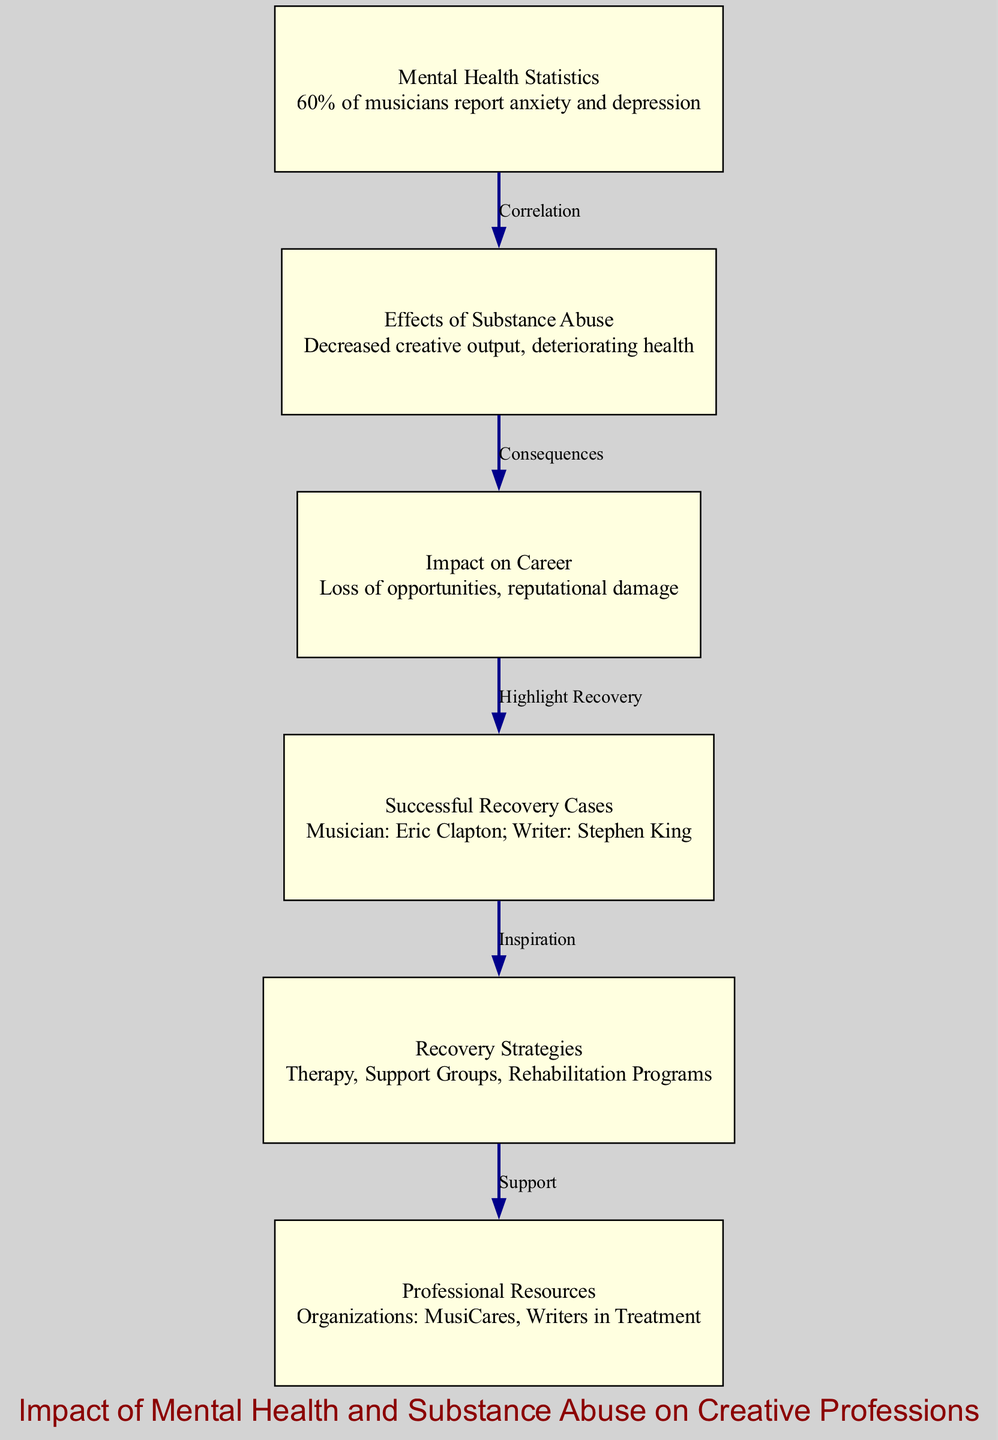What percentage of musicians report anxiety and depression? The diagram states that 60% of musicians report anxiety and depression, which is found in the "Mental Health Statistics" node.
Answer: 60% What are the effects of substance abuse according to the diagram? The "Effects of Substance Abuse" node mentions "Decreased creative output, deteriorating health." This information directly describes the negative consequences of substance abuse.
Answer: Decreased creative output, deteriorating health What is one of the consequences of an impact on career? The "Impact on Career" node indicates "Loss of opportunities, reputational damage." This demonstrates how career paths can be affected negatively due to mental health or substance issues.
Answer: Loss of opportunities Who is one successful musician mentioned in recovery cases? In the "Successful Recovery Cases" node, Eric Clapton is specifically cited as a successful musician, showcasing that recovery is possible in the music industry.
Answer: Eric Clapton How do recovery strategies relate to professional resources? The connection between the "Recovery Strategies" node and "Professional Resources" node is labeled as "Support." This indicates that the resources available can aid in the recovery process.
Answer: Support What can be derived about the relationship between mental health and substance abuse? The "Correlation" edge between "Mental Health Statistics" and "Effects of Substance Abuse" suggests that there is a significant link; the implication is that poor mental health can lead to substance abuse.
Answer: Correlation How many nodes are present in the diagram? By counting the nodes listed in the data, there are six distinct nodes identified in the diagram, each focusing on a different aspect of the topic.
Answer: 6 Which two organizations are mentioned as professional resources? The "Professional Resources" node lists "Organizations: MusiCares, Writers in Treatment", highlighting specific support organizations available for creative professionals.
Answer: MusiCares, Writers in Treatment What highlights successful recovery according to the flow of the diagram? The edge labeled "Highlight Recovery" connects "Impact on Career" and "Successful Recovery Cases," suggesting that the repercussions of career impacts can lead to emphasizing those who have successfully recovered.
Answer: Highlight Recovery 